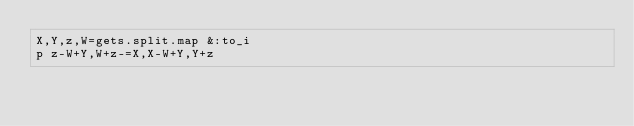<code> <loc_0><loc_0><loc_500><loc_500><_Ruby_>X,Y,z,W=gets.split.map &:to_i
p z-W+Y,W+z-=X,X-W+Y,Y+z</code> 